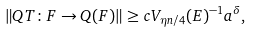Convert formula to latex. <formula><loc_0><loc_0><loc_500><loc_500>\| Q T \colon F \to Q ( F ) \| \geq c V _ { \eta n / 4 } ( E ) ^ { - 1 } { a } ^ { \delta } ,</formula> 